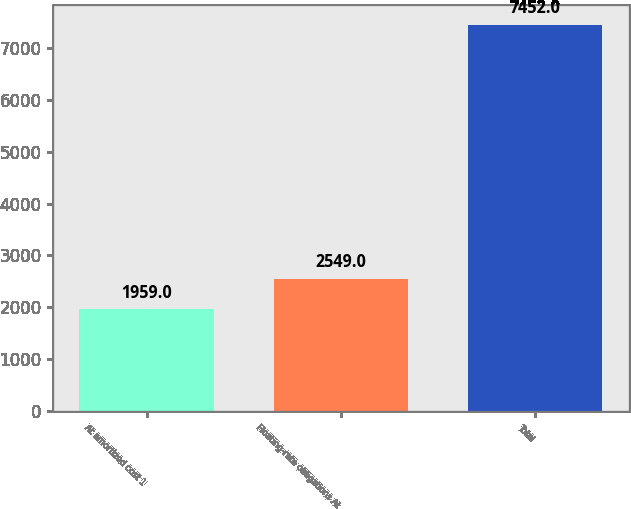<chart> <loc_0><loc_0><loc_500><loc_500><bar_chart><fcel>At amortized cost 1<fcel>Floating-rate obligations At<fcel>Total<nl><fcel>1959<fcel>2549<fcel>7452<nl></chart> 